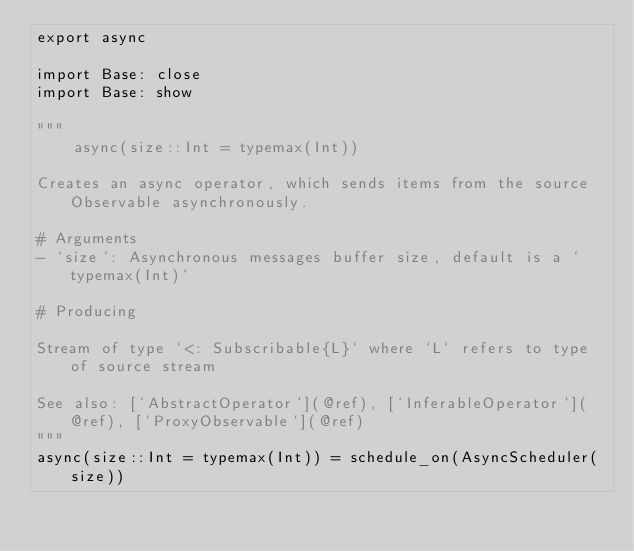<code> <loc_0><loc_0><loc_500><loc_500><_Julia_>export async

import Base: close
import Base: show

"""
    async(size::Int = typemax(Int))

Creates an async operator, which sends items from the source Observable asynchronously.

# Arguments
- `size`: Asynchronous messages buffer size, default is a `typemax(Int)`

# Producing

Stream of type `<: Subscribable{L}` where `L` refers to type of source stream

See also: [`AbstractOperator`](@ref), [`InferableOperator`](@ref), [`ProxyObservable`](@ref)
"""
async(size::Int = typemax(Int)) = schedule_on(AsyncScheduler(size))
</code> 